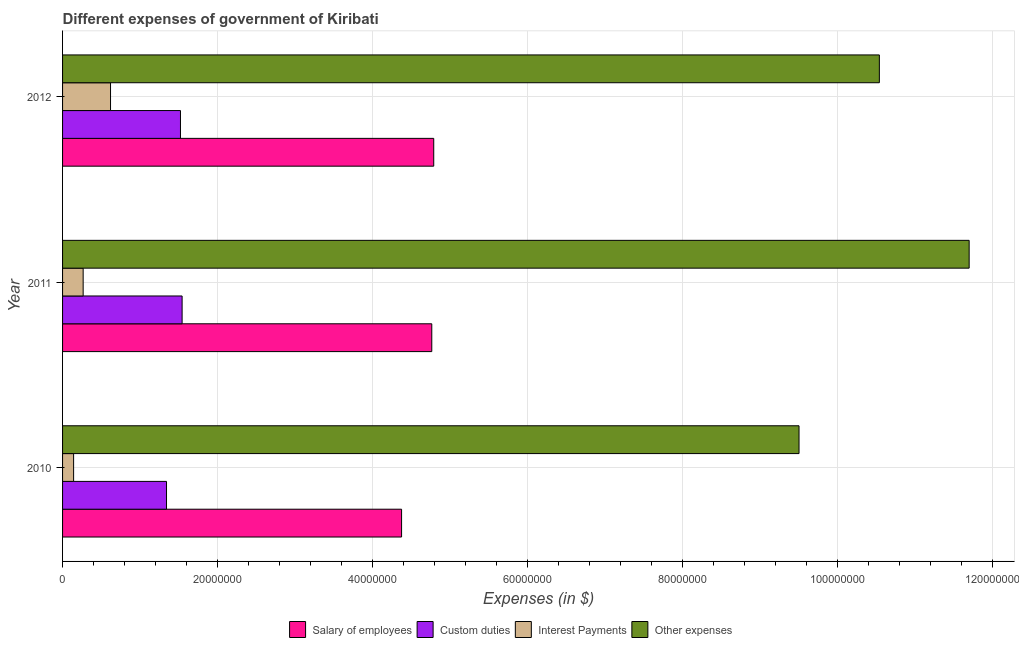How many groups of bars are there?
Your answer should be compact. 3. Are the number of bars on each tick of the Y-axis equal?
Give a very brief answer. Yes. How many bars are there on the 1st tick from the bottom?
Your answer should be compact. 4. What is the label of the 2nd group of bars from the top?
Provide a succinct answer. 2011. What is the amount spent on interest payments in 2010?
Make the answer very short. 1.42e+06. Across all years, what is the maximum amount spent on other expenses?
Make the answer very short. 1.17e+08. Across all years, what is the minimum amount spent on interest payments?
Ensure brevity in your answer.  1.42e+06. In which year was the amount spent on interest payments maximum?
Keep it short and to the point. 2012. What is the total amount spent on salary of employees in the graph?
Provide a succinct answer. 1.39e+08. What is the difference between the amount spent on salary of employees in 2011 and that in 2012?
Provide a short and direct response. -2.51e+05. What is the difference between the amount spent on other expenses in 2010 and the amount spent on custom duties in 2012?
Provide a succinct answer. 7.98e+07. What is the average amount spent on interest payments per year?
Your response must be concise. 3.42e+06. In the year 2010, what is the difference between the amount spent on salary of employees and amount spent on interest payments?
Provide a short and direct response. 4.23e+07. What is the ratio of the amount spent on interest payments in 2010 to that in 2012?
Provide a succinct answer. 0.23. Is the amount spent on interest payments in 2010 less than that in 2011?
Your answer should be compact. Yes. What is the difference between the highest and the second highest amount spent on other expenses?
Offer a very short reply. 1.16e+07. What is the difference between the highest and the lowest amount spent on other expenses?
Keep it short and to the point. 2.20e+07. In how many years, is the amount spent on interest payments greater than the average amount spent on interest payments taken over all years?
Provide a short and direct response. 1. What does the 3rd bar from the top in 2012 represents?
Keep it short and to the point. Custom duties. What does the 3rd bar from the bottom in 2012 represents?
Your answer should be compact. Interest Payments. Is it the case that in every year, the sum of the amount spent on salary of employees and amount spent on custom duties is greater than the amount spent on interest payments?
Make the answer very short. Yes. How many bars are there?
Offer a very short reply. 12. Does the graph contain grids?
Offer a terse response. Yes. Where does the legend appear in the graph?
Give a very brief answer. Bottom center. How many legend labels are there?
Your answer should be compact. 4. How are the legend labels stacked?
Offer a terse response. Horizontal. What is the title of the graph?
Your answer should be compact. Different expenses of government of Kiribati. What is the label or title of the X-axis?
Provide a succinct answer. Expenses (in $). What is the Expenses (in $) in Salary of employees in 2010?
Provide a succinct answer. 4.37e+07. What is the Expenses (in $) of Custom duties in 2010?
Offer a terse response. 1.34e+07. What is the Expenses (in $) of Interest Payments in 2010?
Make the answer very short. 1.42e+06. What is the Expenses (in $) in Other expenses in 2010?
Offer a very short reply. 9.50e+07. What is the Expenses (in $) of Salary of employees in 2011?
Keep it short and to the point. 4.76e+07. What is the Expenses (in $) in Custom duties in 2011?
Your response must be concise. 1.54e+07. What is the Expenses (in $) in Interest Payments in 2011?
Ensure brevity in your answer.  2.66e+06. What is the Expenses (in $) of Other expenses in 2011?
Provide a short and direct response. 1.17e+08. What is the Expenses (in $) in Salary of employees in 2012?
Make the answer very short. 4.79e+07. What is the Expenses (in $) in Custom duties in 2012?
Your response must be concise. 1.52e+07. What is the Expenses (in $) of Interest Payments in 2012?
Give a very brief answer. 6.19e+06. What is the Expenses (in $) in Other expenses in 2012?
Make the answer very short. 1.05e+08. Across all years, what is the maximum Expenses (in $) in Salary of employees?
Provide a short and direct response. 4.79e+07. Across all years, what is the maximum Expenses (in $) of Custom duties?
Your response must be concise. 1.54e+07. Across all years, what is the maximum Expenses (in $) of Interest Payments?
Your answer should be compact. 6.19e+06. Across all years, what is the maximum Expenses (in $) of Other expenses?
Offer a very short reply. 1.17e+08. Across all years, what is the minimum Expenses (in $) in Salary of employees?
Your answer should be very brief. 4.37e+07. Across all years, what is the minimum Expenses (in $) in Custom duties?
Provide a succinct answer. 1.34e+07. Across all years, what is the minimum Expenses (in $) in Interest Payments?
Make the answer very short. 1.42e+06. Across all years, what is the minimum Expenses (in $) in Other expenses?
Make the answer very short. 9.50e+07. What is the total Expenses (in $) in Salary of employees in the graph?
Give a very brief answer. 1.39e+08. What is the total Expenses (in $) in Custom duties in the graph?
Keep it short and to the point. 4.41e+07. What is the total Expenses (in $) in Interest Payments in the graph?
Offer a terse response. 1.03e+07. What is the total Expenses (in $) in Other expenses in the graph?
Your answer should be very brief. 3.17e+08. What is the difference between the Expenses (in $) of Salary of employees in 2010 and that in 2011?
Give a very brief answer. -3.90e+06. What is the difference between the Expenses (in $) of Custom duties in 2010 and that in 2011?
Your response must be concise. -2.01e+06. What is the difference between the Expenses (in $) in Interest Payments in 2010 and that in 2011?
Offer a terse response. -1.23e+06. What is the difference between the Expenses (in $) of Other expenses in 2010 and that in 2011?
Your response must be concise. -2.20e+07. What is the difference between the Expenses (in $) in Salary of employees in 2010 and that in 2012?
Your response must be concise. -4.15e+06. What is the difference between the Expenses (in $) of Custom duties in 2010 and that in 2012?
Provide a succinct answer. -1.80e+06. What is the difference between the Expenses (in $) in Interest Payments in 2010 and that in 2012?
Your answer should be compact. -4.76e+06. What is the difference between the Expenses (in $) in Other expenses in 2010 and that in 2012?
Provide a short and direct response. -1.04e+07. What is the difference between the Expenses (in $) of Salary of employees in 2011 and that in 2012?
Your response must be concise. -2.51e+05. What is the difference between the Expenses (in $) of Custom duties in 2011 and that in 2012?
Your answer should be compact. 2.13e+05. What is the difference between the Expenses (in $) of Interest Payments in 2011 and that in 2012?
Provide a short and direct response. -3.53e+06. What is the difference between the Expenses (in $) of Other expenses in 2011 and that in 2012?
Your answer should be compact. 1.16e+07. What is the difference between the Expenses (in $) of Salary of employees in 2010 and the Expenses (in $) of Custom duties in 2011?
Ensure brevity in your answer.  2.83e+07. What is the difference between the Expenses (in $) in Salary of employees in 2010 and the Expenses (in $) in Interest Payments in 2011?
Make the answer very short. 4.11e+07. What is the difference between the Expenses (in $) of Salary of employees in 2010 and the Expenses (in $) of Other expenses in 2011?
Provide a succinct answer. -7.32e+07. What is the difference between the Expenses (in $) of Custom duties in 2010 and the Expenses (in $) of Interest Payments in 2011?
Provide a succinct answer. 1.08e+07. What is the difference between the Expenses (in $) of Custom duties in 2010 and the Expenses (in $) of Other expenses in 2011?
Offer a very short reply. -1.04e+08. What is the difference between the Expenses (in $) of Interest Payments in 2010 and the Expenses (in $) of Other expenses in 2011?
Ensure brevity in your answer.  -1.16e+08. What is the difference between the Expenses (in $) of Salary of employees in 2010 and the Expenses (in $) of Custom duties in 2012?
Provide a short and direct response. 2.85e+07. What is the difference between the Expenses (in $) in Salary of employees in 2010 and the Expenses (in $) in Interest Payments in 2012?
Provide a succinct answer. 3.76e+07. What is the difference between the Expenses (in $) of Salary of employees in 2010 and the Expenses (in $) of Other expenses in 2012?
Make the answer very short. -6.17e+07. What is the difference between the Expenses (in $) of Custom duties in 2010 and the Expenses (in $) of Interest Payments in 2012?
Keep it short and to the point. 7.23e+06. What is the difference between the Expenses (in $) in Custom duties in 2010 and the Expenses (in $) in Other expenses in 2012?
Offer a terse response. -9.20e+07. What is the difference between the Expenses (in $) in Interest Payments in 2010 and the Expenses (in $) in Other expenses in 2012?
Your answer should be compact. -1.04e+08. What is the difference between the Expenses (in $) of Salary of employees in 2011 and the Expenses (in $) of Custom duties in 2012?
Give a very brief answer. 3.24e+07. What is the difference between the Expenses (in $) in Salary of employees in 2011 and the Expenses (in $) in Interest Payments in 2012?
Offer a very short reply. 4.15e+07. What is the difference between the Expenses (in $) in Salary of employees in 2011 and the Expenses (in $) in Other expenses in 2012?
Ensure brevity in your answer.  -5.78e+07. What is the difference between the Expenses (in $) of Custom duties in 2011 and the Expenses (in $) of Interest Payments in 2012?
Your response must be concise. 9.24e+06. What is the difference between the Expenses (in $) in Custom duties in 2011 and the Expenses (in $) in Other expenses in 2012?
Your answer should be very brief. -9.00e+07. What is the difference between the Expenses (in $) in Interest Payments in 2011 and the Expenses (in $) in Other expenses in 2012?
Keep it short and to the point. -1.03e+08. What is the average Expenses (in $) of Salary of employees per year?
Make the answer very short. 4.64e+07. What is the average Expenses (in $) of Custom duties per year?
Keep it short and to the point. 1.47e+07. What is the average Expenses (in $) in Interest Payments per year?
Your answer should be very brief. 3.42e+06. What is the average Expenses (in $) in Other expenses per year?
Your response must be concise. 1.06e+08. In the year 2010, what is the difference between the Expenses (in $) of Salary of employees and Expenses (in $) of Custom duties?
Make the answer very short. 3.03e+07. In the year 2010, what is the difference between the Expenses (in $) in Salary of employees and Expenses (in $) in Interest Payments?
Your response must be concise. 4.23e+07. In the year 2010, what is the difference between the Expenses (in $) of Salary of employees and Expenses (in $) of Other expenses?
Keep it short and to the point. -5.13e+07. In the year 2010, what is the difference between the Expenses (in $) in Custom duties and Expenses (in $) in Interest Payments?
Offer a very short reply. 1.20e+07. In the year 2010, what is the difference between the Expenses (in $) in Custom duties and Expenses (in $) in Other expenses?
Offer a terse response. -8.16e+07. In the year 2010, what is the difference between the Expenses (in $) in Interest Payments and Expenses (in $) in Other expenses?
Offer a very short reply. -9.36e+07. In the year 2011, what is the difference between the Expenses (in $) of Salary of employees and Expenses (in $) of Custom duties?
Keep it short and to the point. 3.22e+07. In the year 2011, what is the difference between the Expenses (in $) of Salary of employees and Expenses (in $) of Interest Payments?
Provide a short and direct response. 4.50e+07. In the year 2011, what is the difference between the Expenses (in $) of Salary of employees and Expenses (in $) of Other expenses?
Offer a very short reply. -6.93e+07. In the year 2011, what is the difference between the Expenses (in $) in Custom duties and Expenses (in $) in Interest Payments?
Your answer should be compact. 1.28e+07. In the year 2011, what is the difference between the Expenses (in $) of Custom duties and Expenses (in $) of Other expenses?
Offer a very short reply. -1.02e+08. In the year 2011, what is the difference between the Expenses (in $) of Interest Payments and Expenses (in $) of Other expenses?
Keep it short and to the point. -1.14e+08. In the year 2012, what is the difference between the Expenses (in $) of Salary of employees and Expenses (in $) of Custom duties?
Make the answer very short. 3.27e+07. In the year 2012, what is the difference between the Expenses (in $) of Salary of employees and Expenses (in $) of Interest Payments?
Your response must be concise. 4.17e+07. In the year 2012, what is the difference between the Expenses (in $) in Salary of employees and Expenses (in $) in Other expenses?
Offer a very short reply. -5.75e+07. In the year 2012, what is the difference between the Expenses (in $) of Custom duties and Expenses (in $) of Interest Payments?
Provide a short and direct response. 9.03e+06. In the year 2012, what is the difference between the Expenses (in $) in Custom duties and Expenses (in $) in Other expenses?
Provide a short and direct response. -9.02e+07. In the year 2012, what is the difference between the Expenses (in $) of Interest Payments and Expenses (in $) of Other expenses?
Provide a short and direct response. -9.92e+07. What is the ratio of the Expenses (in $) of Salary of employees in 2010 to that in 2011?
Your answer should be compact. 0.92. What is the ratio of the Expenses (in $) in Custom duties in 2010 to that in 2011?
Offer a very short reply. 0.87. What is the ratio of the Expenses (in $) of Interest Payments in 2010 to that in 2011?
Give a very brief answer. 0.54. What is the ratio of the Expenses (in $) of Other expenses in 2010 to that in 2011?
Offer a terse response. 0.81. What is the ratio of the Expenses (in $) of Salary of employees in 2010 to that in 2012?
Your response must be concise. 0.91. What is the ratio of the Expenses (in $) of Custom duties in 2010 to that in 2012?
Your response must be concise. 0.88. What is the ratio of the Expenses (in $) of Interest Payments in 2010 to that in 2012?
Provide a succinct answer. 0.23. What is the ratio of the Expenses (in $) in Other expenses in 2010 to that in 2012?
Make the answer very short. 0.9. What is the ratio of the Expenses (in $) of Salary of employees in 2011 to that in 2012?
Your answer should be very brief. 0.99. What is the ratio of the Expenses (in $) in Interest Payments in 2011 to that in 2012?
Provide a succinct answer. 0.43. What is the ratio of the Expenses (in $) of Other expenses in 2011 to that in 2012?
Your response must be concise. 1.11. What is the difference between the highest and the second highest Expenses (in $) in Salary of employees?
Ensure brevity in your answer.  2.51e+05. What is the difference between the highest and the second highest Expenses (in $) in Custom duties?
Give a very brief answer. 2.13e+05. What is the difference between the highest and the second highest Expenses (in $) of Interest Payments?
Give a very brief answer. 3.53e+06. What is the difference between the highest and the second highest Expenses (in $) of Other expenses?
Make the answer very short. 1.16e+07. What is the difference between the highest and the lowest Expenses (in $) in Salary of employees?
Keep it short and to the point. 4.15e+06. What is the difference between the highest and the lowest Expenses (in $) of Custom duties?
Your answer should be very brief. 2.01e+06. What is the difference between the highest and the lowest Expenses (in $) of Interest Payments?
Your response must be concise. 4.76e+06. What is the difference between the highest and the lowest Expenses (in $) of Other expenses?
Offer a very short reply. 2.20e+07. 